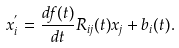Convert formula to latex. <formula><loc_0><loc_0><loc_500><loc_500>x ^ { ^ { \prime } } _ { i } = \frac { d f ( t ) } { d t } R _ { i j } ( t ) x _ { j } + b _ { i } ( t ) .</formula> 